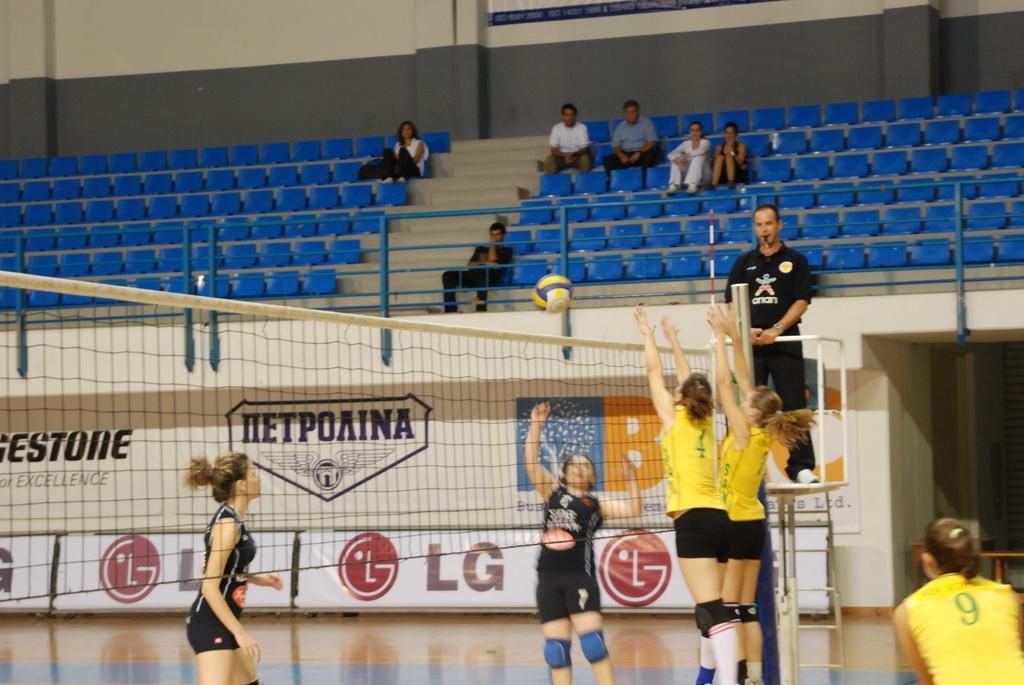Please provide a concise description of this image. In this picture there are girls in the center of the image in front of a net, they are playing and there are people those who are sitting on the chairs at the top side of the image and there are posters in the image. 